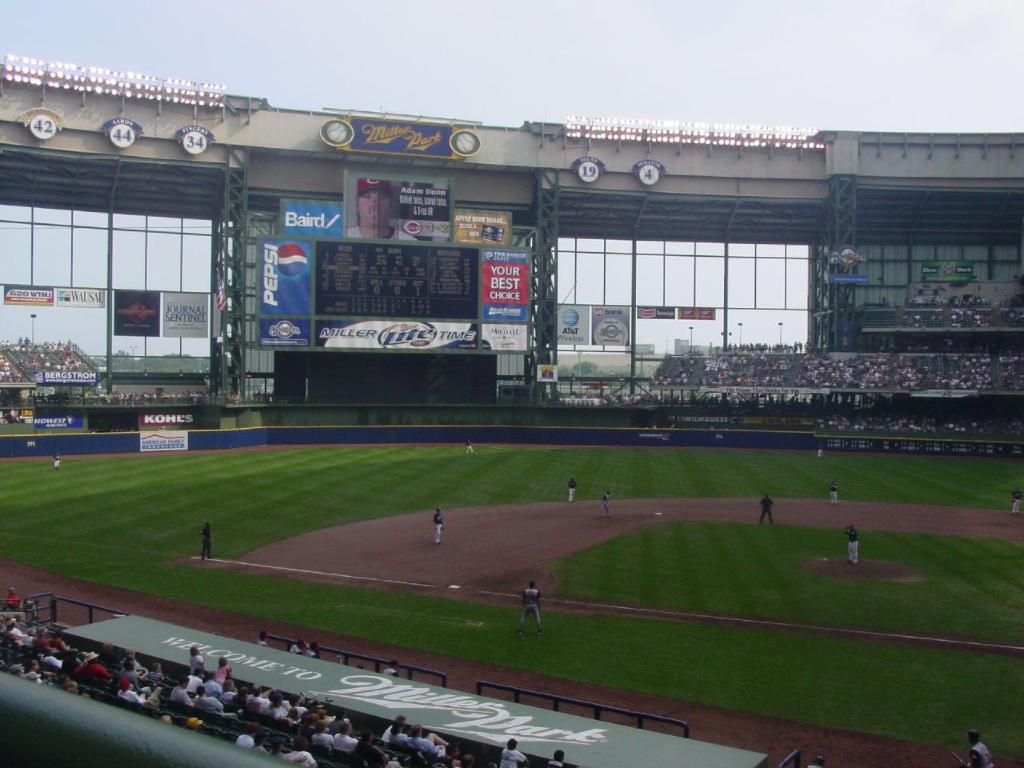What is the baseball field called?
Keep it short and to the point. Miller park. Who is the sponsor of the field?
Give a very brief answer. Pepsi. 